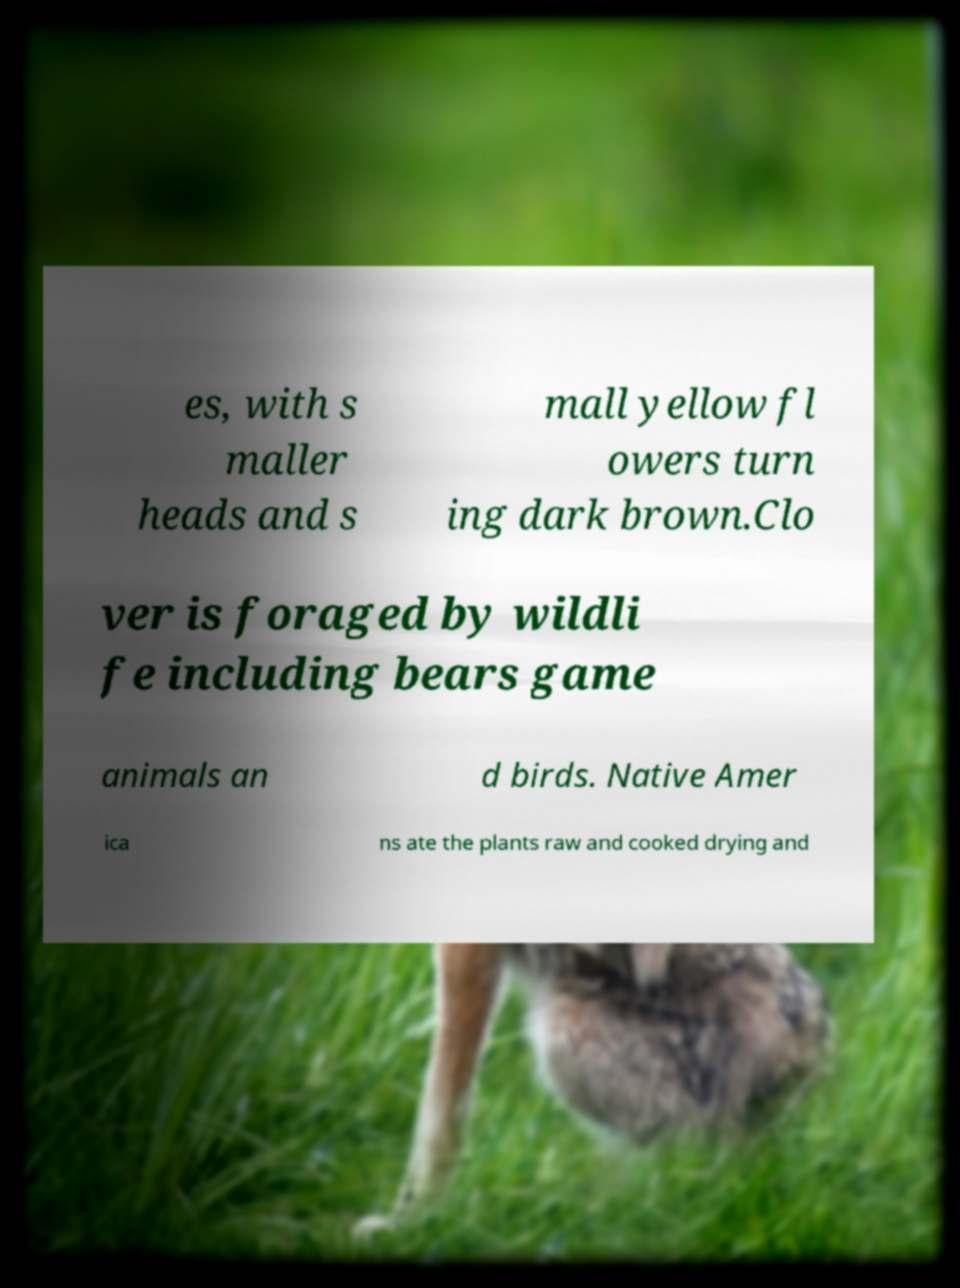Please identify and transcribe the text found in this image. es, with s maller heads and s mall yellow fl owers turn ing dark brown.Clo ver is foraged by wildli fe including bears game animals an d birds. Native Amer ica ns ate the plants raw and cooked drying and 